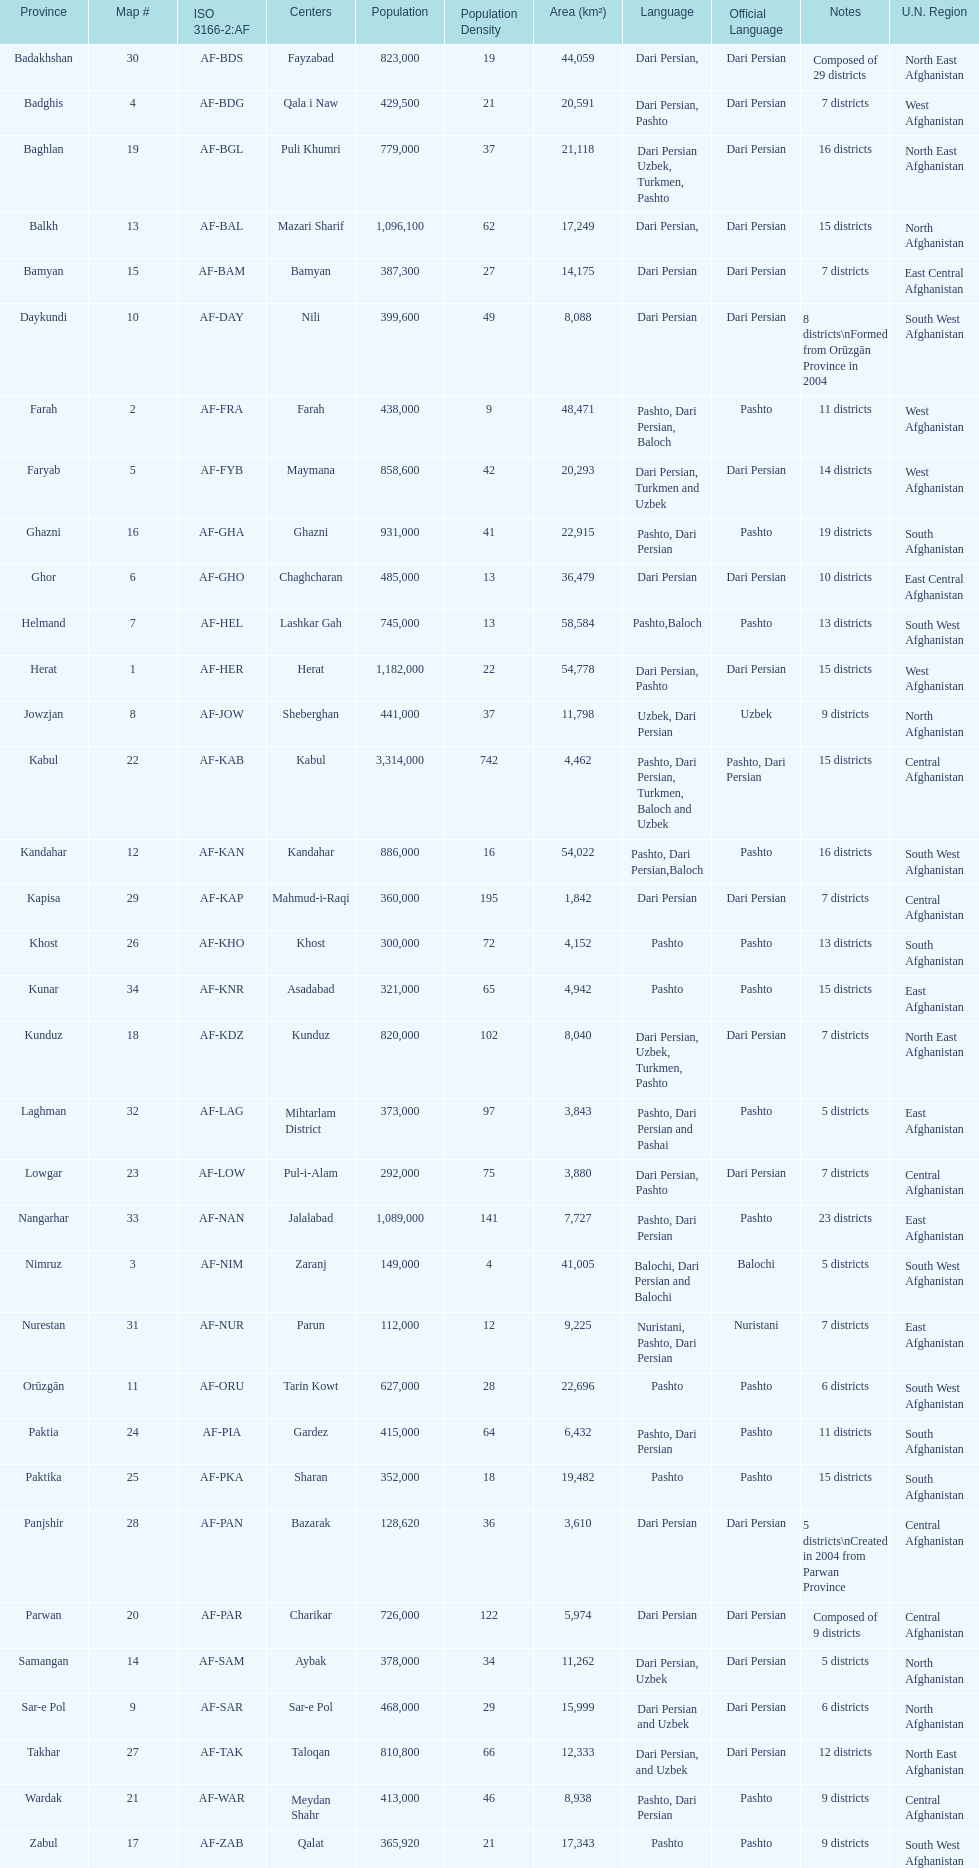How many districts are in the province of kunduz? 7. 